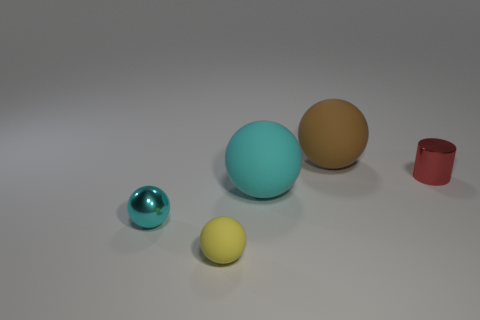Add 1 tiny brown metallic cubes. How many objects exist? 6 Subtract all balls. How many objects are left? 1 Add 4 purple metallic cylinders. How many purple metallic cylinders exist? 4 Subtract 1 yellow spheres. How many objects are left? 4 Subtract all yellow cylinders. Subtract all small red metal objects. How many objects are left? 4 Add 1 cylinders. How many cylinders are left? 2 